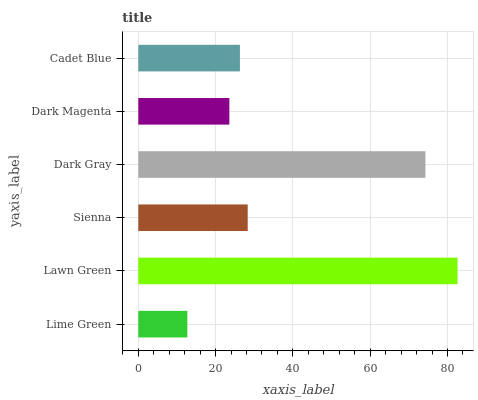Is Lime Green the minimum?
Answer yes or no. Yes. Is Lawn Green the maximum?
Answer yes or no. Yes. Is Sienna the minimum?
Answer yes or no. No. Is Sienna the maximum?
Answer yes or no. No. Is Lawn Green greater than Sienna?
Answer yes or no. Yes. Is Sienna less than Lawn Green?
Answer yes or no. Yes. Is Sienna greater than Lawn Green?
Answer yes or no. No. Is Lawn Green less than Sienna?
Answer yes or no. No. Is Sienna the high median?
Answer yes or no. Yes. Is Cadet Blue the low median?
Answer yes or no. Yes. Is Lime Green the high median?
Answer yes or no. No. Is Sienna the low median?
Answer yes or no. No. 